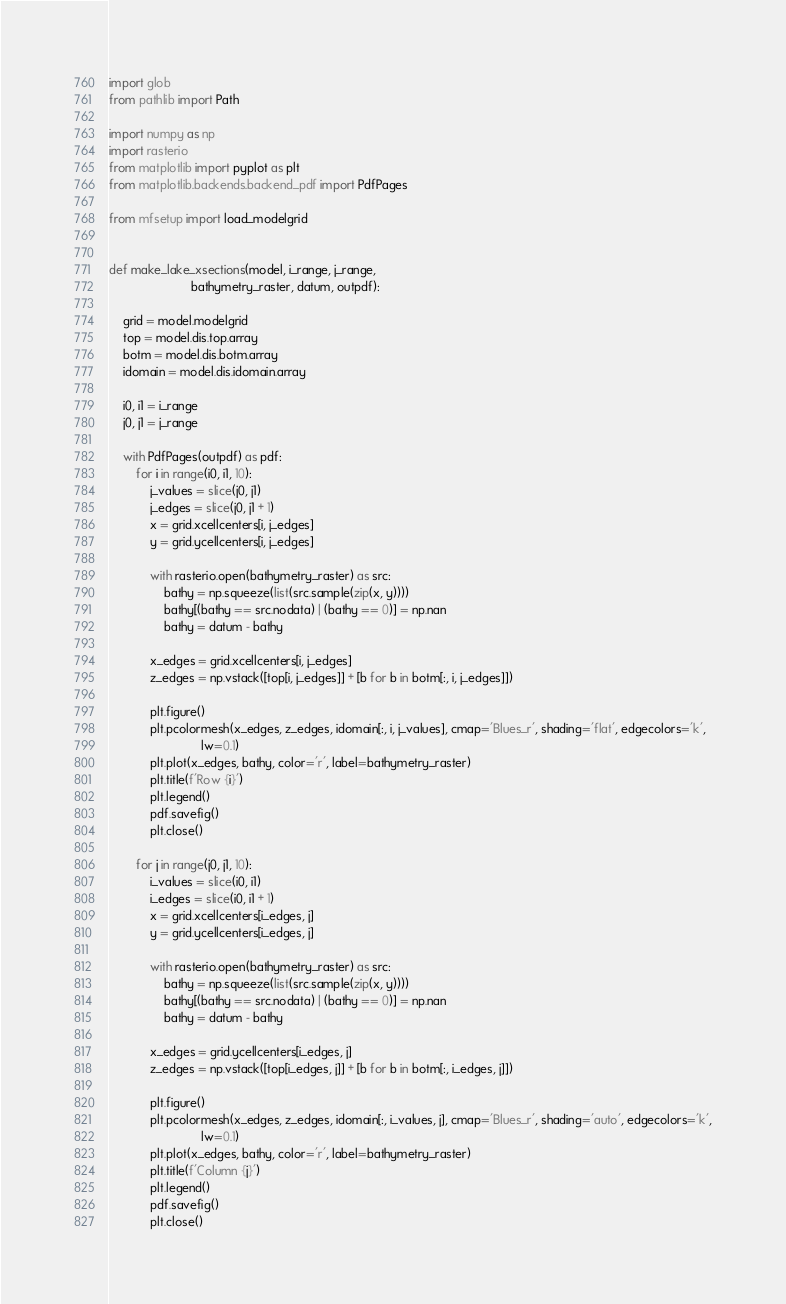Convert code to text. <code><loc_0><loc_0><loc_500><loc_500><_Python_>import glob
from pathlib import Path

import numpy as np
import rasterio
from matplotlib import pyplot as plt
from matplotlib.backends.backend_pdf import PdfPages

from mfsetup import load_modelgrid


def make_lake_xsections(model, i_range, j_range,
                        bathymetry_raster, datum, outpdf):

    grid = model.modelgrid
    top = model.dis.top.array
    botm = model.dis.botm.array
    idomain = model.dis.idomain.array

    i0, i1 = i_range
    j0, j1 = j_range

    with PdfPages(outpdf) as pdf:
        for i in range(i0, i1, 10):
            j_values = slice(j0, j1)
            j_edges = slice(j0, j1 + 1)
            x = grid.xcellcenters[i, j_edges]
            y = grid.ycellcenters[i, j_edges]

            with rasterio.open(bathymetry_raster) as src:
                bathy = np.squeeze(list(src.sample(zip(x, y))))
                bathy[(bathy == src.nodata) | (bathy == 0)] = np.nan
                bathy = datum - bathy

            x_edges = grid.xcellcenters[i, j_edges]
            z_edges = np.vstack([top[i, j_edges]] + [b for b in botm[:, i, j_edges]])

            plt.figure()
            plt.pcolormesh(x_edges, z_edges, idomain[:, i, j_values], cmap='Blues_r', shading='flat', edgecolors='k',
                           lw=0.1)
            plt.plot(x_edges, bathy, color='r', label=bathymetry_raster)
            plt.title(f'Row {i}')
            plt.legend()
            pdf.savefig()
            plt.close()

        for j in range(j0, j1, 10):
            i_values = slice(i0, i1)
            i_edges = slice(i0, i1 + 1)
            x = grid.xcellcenters[i_edges, j]
            y = grid.ycellcenters[i_edges, j]

            with rasterio.open(bathymetry_raster) as src:
                bathy = np.squeeze(list(src.sample(zip(x, y))))
                bathy[(bathy == src.nodata) | (bathy == 0)] = np.nan
                bathy = datum - bathy

            x_edges = grid.ycellcenters[i_edges, j]
            z_edges = np.vstack([top[i_edges, j]] + [b for b in botm[:, i_edges, j]])

            plt.figure()
            plt.pcolormesh(x_edges, z_edges, idomain[:, i_values, j], cmap='Blues_r', shading='auto', edgecolors='k',
                           lw=0.1)
            plt.plot(x_edges, bathy, color='r', label=bathymetry_raster)
            plt.title(f'Column {j}')
            plt.legend()
            pdf.savefig()
            plt.close()
</code> 